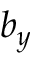Convert formula to latex. <formula><loc_0><loc_0><loc_500><loc_500>b _ { y }</formula> 